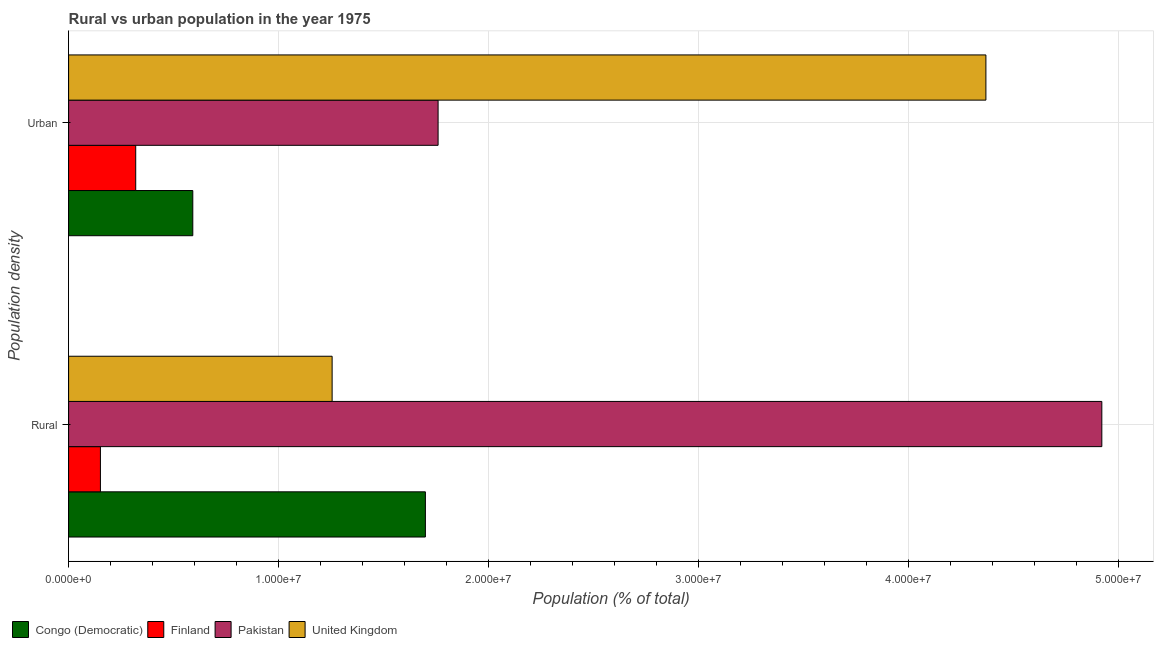Are the number of bars per tick equal to the number of legend labels?
Keep it short and to the point. Yes. How many bars are there on the 1st tick from the top?
Give a very brief answer. 4. How many bars are there on the 1st tick from the bottom?
Your answer should be very brief. 4. What is the label of the 2nd group of bars from the top?
Give a very brief answer. Rural. What is the rural population density in Congo (Democratic)?
Offer a very short reply. 1.70e+07. Across all countries, what is the maximum rural population density?
Your answer should be very brief. 4.92e+07. Across all countries, what is the minimum rural population density?
Offer a terse response. 1.52e+06. In which country was the rural population density maximum?
Give a very brief answer. Pakistan. In which country was the rural population density minimum?
Make the answer very short. Finland. What is the total rural population density in the graph?
Keep it short and to the point. 8.03e+07. What is the difference between the rural population density in Congo (Democratic) and that in Finland?
Keep it short and to the point. 1.55e+07. What is the difference between the urban population density in United Kingdom and the rural population density in Congo (Democratic)?
Your answer should be compact. 2.67e+07. What is the average urban population density per country?
Ensure brevity in your answer.  1.76e+07. What is the difference between the urban population density and rural population density in Finland?
Offer a terse response. 1.68e+06. What is the ratio of the urban population density in United Kingdom to that in Congo (Democratic)?
Give a very brief answer. 7.39. Is the rural population density in Congo (Democratic) less than that in United Kingdom?
Your answer should be very brief. No. In how many countries, is the rural population density greater than the average rural population density taken over all countries?
Offer a very short reply. 1. What does the 3rd bar from the top in Rural represents?
Offer a terse response. Finland. What does the 2nd bar from the bottom in Urban represents?
Provide a succinct answer. Finland. How many bars are there?
Your response must be concise. 8. Are all the bars in the graph horizontal?
Ensure brevity in your answer.  Yes. What is the difference between two consecutive major ticks on the X-axis?
Your answer should be very brief. 1.00e+07. Are the values on the major ticks of X-axis written in scientific E-notation?
Provide a succinct answer. Yes. Does the graph contain any zero values?
Give a very brief answer. No. How are the legend labels stacked?
Offer a terse response. Horizontal. What is the title of the graph?
Make the answer very short. Rural vs urban population in the year 1975. What is the label or title of the X-axis?
Keep it short and to the point. Population (% of total). What is the label or title of the Y-axis?
Provide a succinct answer. Population density. What is the Population (% of total) in Congo (Democratic) in Rural?
Give a very brief answer. 1.70e+07. What is the Population (% of total) in Finland in Rural?
Offer a very short reply. 1.52e+06. What is the Population (% of total) in Pakistan in Rural?
Provide a succinct answer. 4.92e+07. What is the Population (% of total) of United Kingdom in Rural?
Your response must be concise. 1.25e+07. What is the Population (% of total) of Congo (Democratic) in Urban?
Offer a terse response. 5.91e+06. What is the Population (% of total) in Finland in Urban?
Keep it short and to the point. 3.20e+06. What is the Population (% of total) in Pakistan in Urban?
Ensure brevity in your answer.  1.76e+07. What is the Population (% of total) in United Kingdom in Urban?
Give a very brief answer. 4.37e+07. Across all Population density, what is the maximum Population (% of total) in Congo (Democratic)?
Keep it short and to the point. 1.70e+07. Across all Population density, what is the maximum Population (% of total) of Finland?
Provide a short and direct response. 3.20e+06. Across all Population density, what is the maximum Population (% of total) of Pakistan?
Offer a very short reply. 4.92e+07. Across all Population density, what is the maximum Population (% of total) in United Kingdom?
Ensure brevity in your answer.  4.37e+07. Across all Population density, what is the minimum Population (% of total) in Congo (Democratic)?
Your response must be concise. 5.91e+06. Across all Population density, what is the minimum Population (% of total) of Finland?
Make the answer very short. 1.52e+06. Across all Population density, what is the minimum Population (% of total) of Pakistan?
Provide a succinct answer. 1.76e+07. Across all Population density, what is the minimum Population (% of total) in United Kingdom?
Provide a short and direct response. 1.25e+07. What is the total Population (% of total) of Congo (Democratic) in the graph?
Provide a short and direct response. 2.29e+07. What is the total Population (% of total) of Finland in the graph?
Make the answer very short. 4.71e+06. What is the total Population (% of total) of Pakistan in the graph?
Keep it short and to the point. 6.68e+07. What is the total Population (% of total) of United Kingdom in the graph?
Provide a succinct answer. 5.62e+07. What is the difference between the Population (% of total) of Congo (Democratic) in Rural and that in Urban?
Your answer should be compact. 1.11e+07. What is the difference between the Population (% of total) of Finland in Rural and that in Urban?
Make the answer very short. -1.68e+06. What is the difference between the Population (% of total) of Pakistan in Rural and that in Urban?
Keep it short and to the point. 3.16e+07. What is the difference between the Population (% of total) of United Kingdom in Rural and that in Urban?
Keep it short and to the point. -3.11e+07. What is the difference between the Population (% of total) in Congo (Democratic) in Rural and the Population (% of total) in Finland in Urban?
Make the answer very short. 1.38e+07. What is the difference between the Population (% of total) of Congo (Democratic) in Rural and the Population (% of total) of Pakistan in Urban?
Offer a very short reply. -6.05e+05. What is the difference between the Population (% of total) in Congo (Democratic) in Rural and the Population (% of total) in United Kingdom in Urban?
Provide a succinct answer. -2.67e+07. What is the difference between the Population (% of total) of Finland in Rural and the Population (% of total) of Pakistan in Urban?
Offer a terse response. -1.61e+07. What is the difference between the Population (% of total) of Finland in Rural and the Population (% of total) of United Kingdom in Urban?
Offer a terse response. -4.22e+07. What is the difference between the Population (% of total) of Pakistan in Rural and the Population (% of total) of United Kingdom in Urban?
Provide a succinct answer. 5.52e+06. What is the average Population (% of total) in Congo (Democratic) per Population density?
Offer a very short reply. 1.15e+07. What is the average Population (% of total) of Finland per Population density?
Keep it short and to the point. 2.36e+06. What is the average Population (% of total) in Pakistan per Population density?
Ensure brevity in your answer.  3.34e+07. What is the average Population (% of total) of United Kingdom per Population density?
Your answer should be very brief. 2.81e+07. What is the difference between the Population (% of total) of Congo (Democratic) and Population (% of total) of Finland in Rural?
Provide a short and direct response. 1.55e+07. What is the difference between the Population (% of total) in Congo (Democratic) and Population (% of total) in Pakistan in Rural?
Your answer should be compact. -3.22e+07. What is the difference between the Population (% of total) in Congo (Democratic) and Population (% of total) in United Kingdom in Rural?
Make the answer very short. 4.44e+06. What is the difference between the Population (% of total) in Finland and Population (% of total) in Pakistan in Rural?
Offer a very short reply. -4.77e+07. What is the difference between the Population (% of total) in Finland and Population (% of total) in United Kingdom in Rural?
Give a very brief answer. -1.10e+07. What is the difference between the Population (% of total) of Pakistan and Population (% of total) of United Kingdom in Rural?
Ensure brevity in your answer.  3.67e+07. What is the difference between the Population (% of total) in Congo (Democratic) and Population (% of total) in Finland in Urban?
Provide a succinct answer. 2.72e+06. What is the difference between the Population (% of total) in Congo (Democratic) and Population (% of total) in Pakistan in Urban?
Keep it short and to the point. -1.17e+07. What is the difference between the Population (% of total) in Congo (Democratic) and Population (% of total) in United Kingdom in Urban?
Give a very brief answer. -3.78e+07. What is the difference between the Population (% of total) in Finland and Population (% of total) in Pakistan in Urban?
Your response must be concise. -1.44e+07. What is the difference between the Population (% of total) of Finland and Population (% of total) of United Kingdom in Urban?
Provide a short and direct response. -4.05e+07. What is the difference between the Population (% of total) in Pakistan and Population (% of total) in United Kingdom in Urban?
Provide a short and direct response. -2.61e+07. What is the ratio of the Population (% of total) of Congo (Democratic) in Rural to that in Urban?
Give a very brief answer. 2.87. What is the ratio of the Population (% of total) of Finland in Rural to that in Urban?
Provide a short and direct response. 0.47. What is the ratio of the Population (% of total) in Pakistan in Rural to that in Urban?
Provide a succinct answer. 2.8. What is the ratio of the Population (% of total) in United Kingdom in Rural to that in Urban?
Provide a succinct answer. 0.29. What is the difference between the highest and the second highest Population (% of total) of Congo (Democratic)?
Offer a terse response. 1.11e+07. What is the difference between the highest and the second highest Population (% of total) in Finland?
Your answer should be compact. 1.68e+06. What is the difference between the highest and the second highest Population (% of total) in Pakistan?
Your answer should be very brief. 3.16e+07. What is the difference between the highest and the second highest Population (% of total) of United Kingdom?
Ensure brevity in your answer.  3.11e+07. What is the difference between the highest and the lowest Population (% of total) of Congo (Democratic)?
Offer a terse response. 1.11e+07. What is the difference between the highest and the lowest Population (% of total) in Finland?
Keep it short and to the point. 1.68e+06. What is the difference between the highest and the lowest Population (% of total) in Pakistan?
Ensure brevity in your answer.  3.16e+07. What is the difference between the highest and the lowest Population (% of total) in United Kingdom?
Your response must be concise. 3.11e+07. 